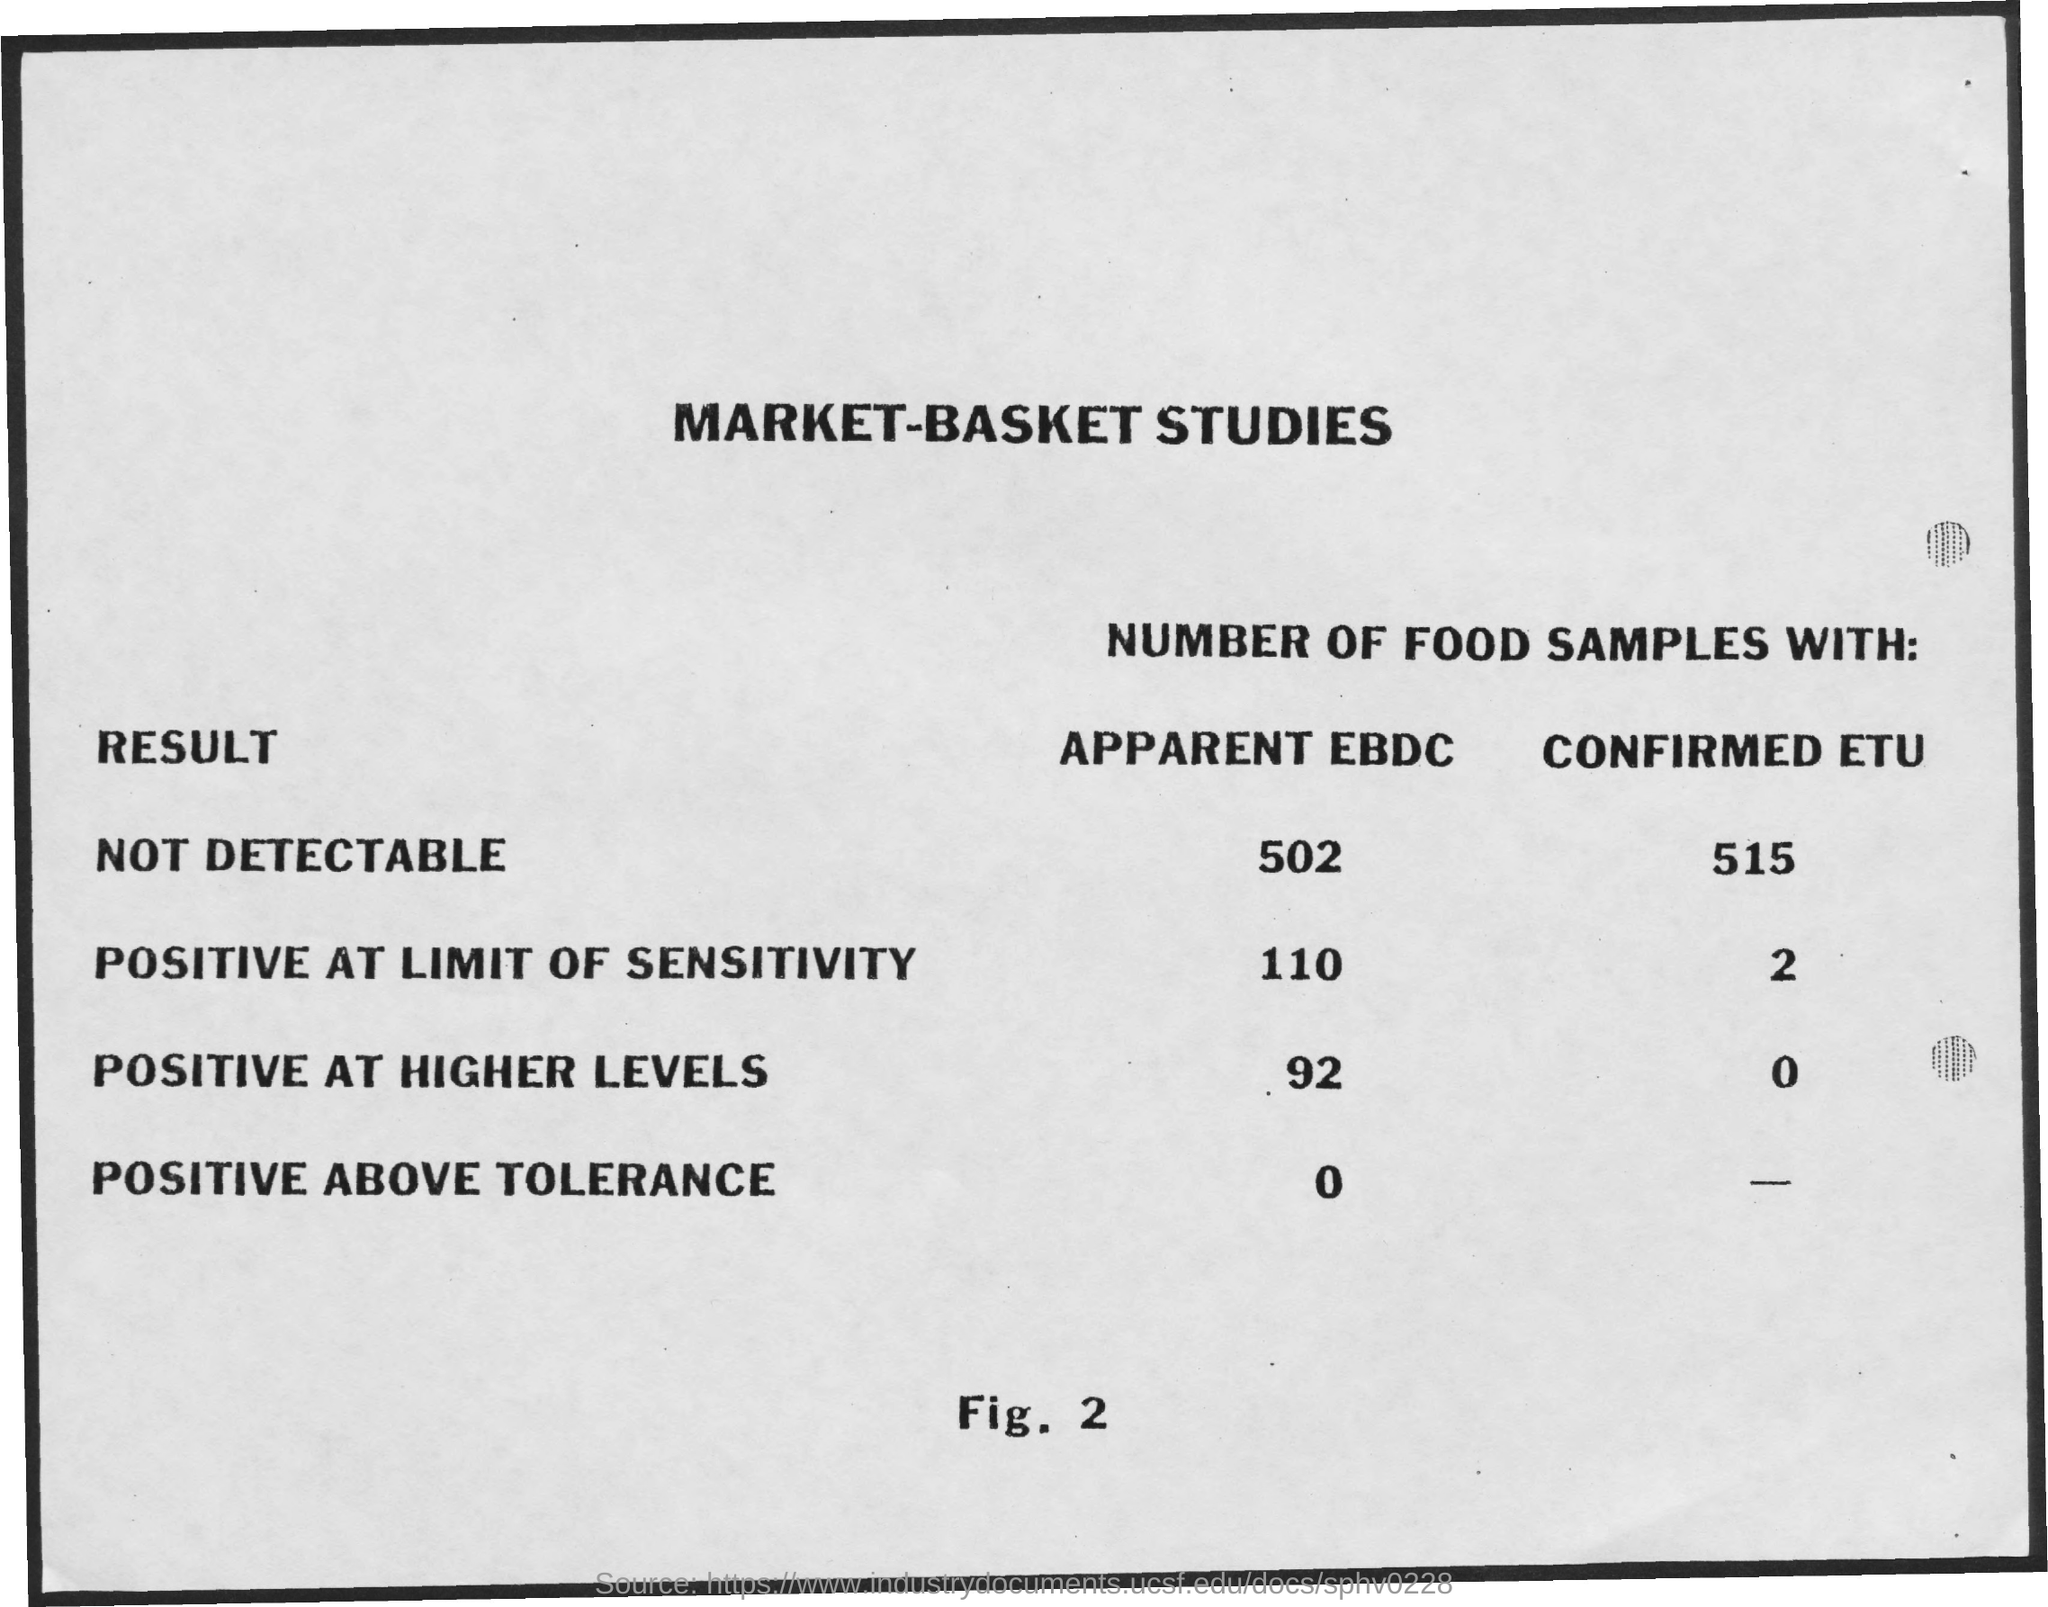Indicate a few pertinent items in this graphic. Out of the total number of food samples tested, 110 samples showed an apparent EBDC result that was positive at the limit of sensitivity. There are no food samples that have confirmed ETU at higher levels and are also positive. The number of food samples with apparent ELSD peak area that is above the tolerance limit is 0. Of the 502 food samples tested, 256 of them were found to have an apparent EBDC level that was not detectable. The study found that 92 out of the 100 food samples tested showed evidence of EBDC at higher levels, with 73 samples testing positive for EBDC. 